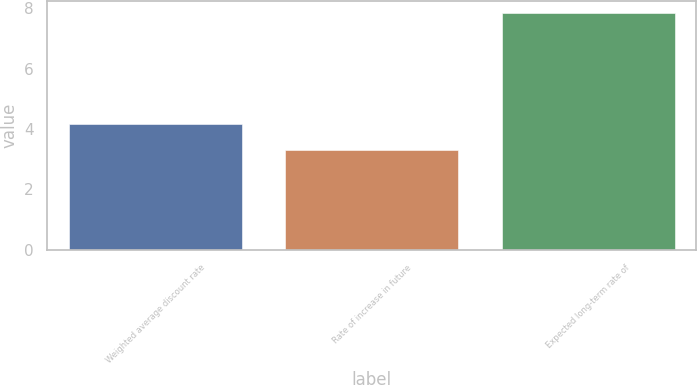Convert chart. <chart><loc_0><loc_0><loc_500><loc_500><bar_chart><fcel>Weighted average discount rate<fcel>Rate of increase in future<fcel>Expected long-term rate of<nl><fcel>4.17<fcel>3.3<fcel>7.83<nl></chart> 